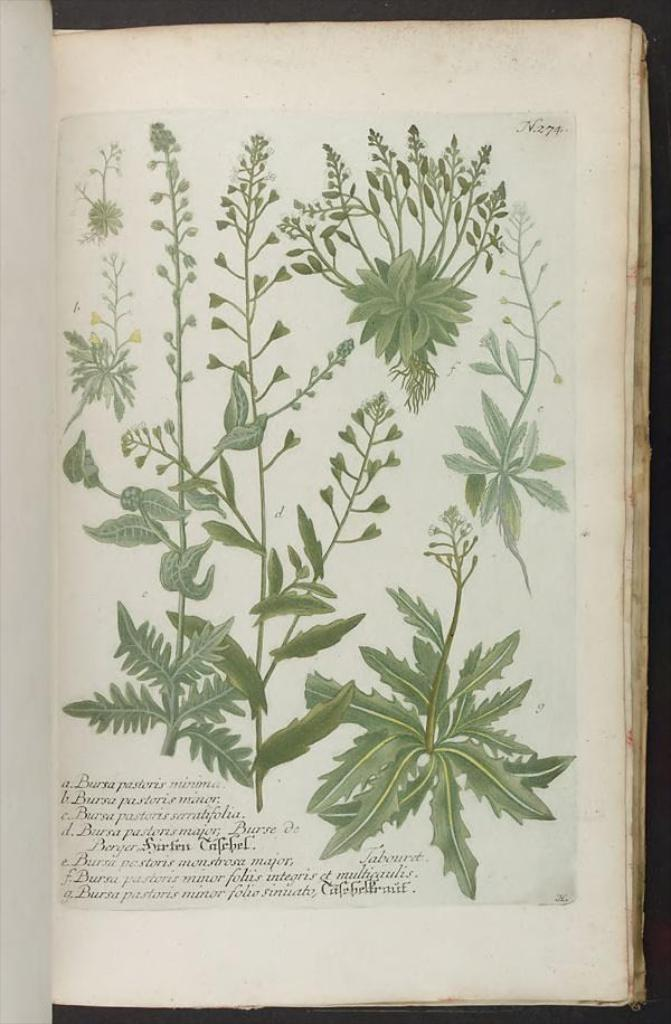What is the main object in the image? There is a book in the image. What is placed on the book? There are plants on the book. What can be read on the book? There is text on the book. What color is the background of the image? The background of the image is black. What color of paint is being used by the leg in the image? There is no leg or paint present in the image; it only features a book with plants and text on it. 